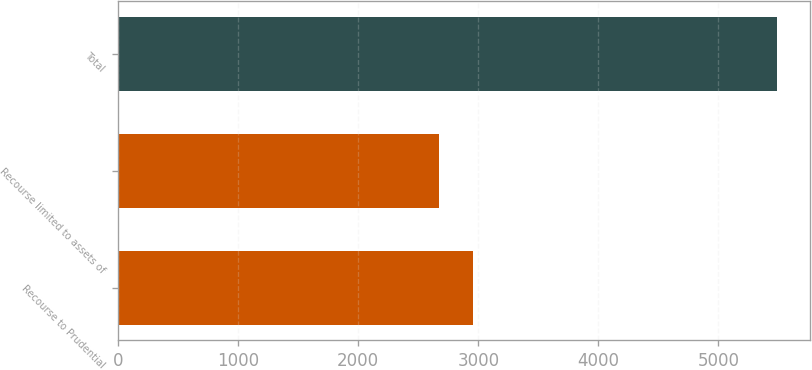Convert chart. <chart><loc_0><loc_0><loc_500><loc_500><bar_chart><fcel>Recourse to Prudential<fcel>Recourse limited to assets of<fcel>Total<nl><fcel>2952.4<fcel>2671<fcel>5485<nl></chart> 